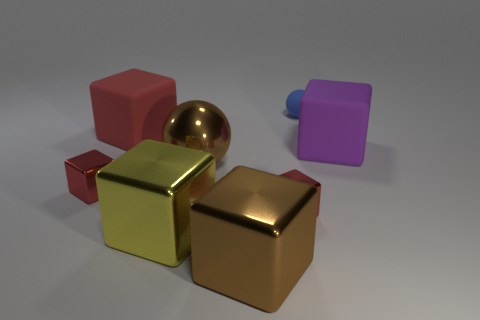Are there more small balls left of the blue object than small blocks?
Offer a terse response. No. How many other objects are there of the same material as the small ball?
Provide a succinct answer. 2. How many small things are either yellow cylinders or red rubber cubes?
Offer a very short reply. 0. Is the material of the blue thing the same as the big purple cube?
Offer a very short reply. Yes. What number of rubber blocks are to the right of the big rubber object that is to the left of the small sphere?
Make the answer very short. 1. Are there any other yellow things of the same shape as the big yellow object?
Offer a very short reply. No. Do the tiny thing that is left of the yellow metal thing and the tiny metallic object that is right of the shiny ball have the same shape?
Your answer should be compact. Yes. The big thing that is in front of the purple thing and behind the yellow metal object has what shape?
Your answer should be compact. Sphere. Are there any shiny objects that have the same size as the brown metallic ball?
Offer a very short reply. Yes. Do the tiny ball and the large rubber object to the left of the small rubber sphere have the same color?
Give a very brief answer. No. 